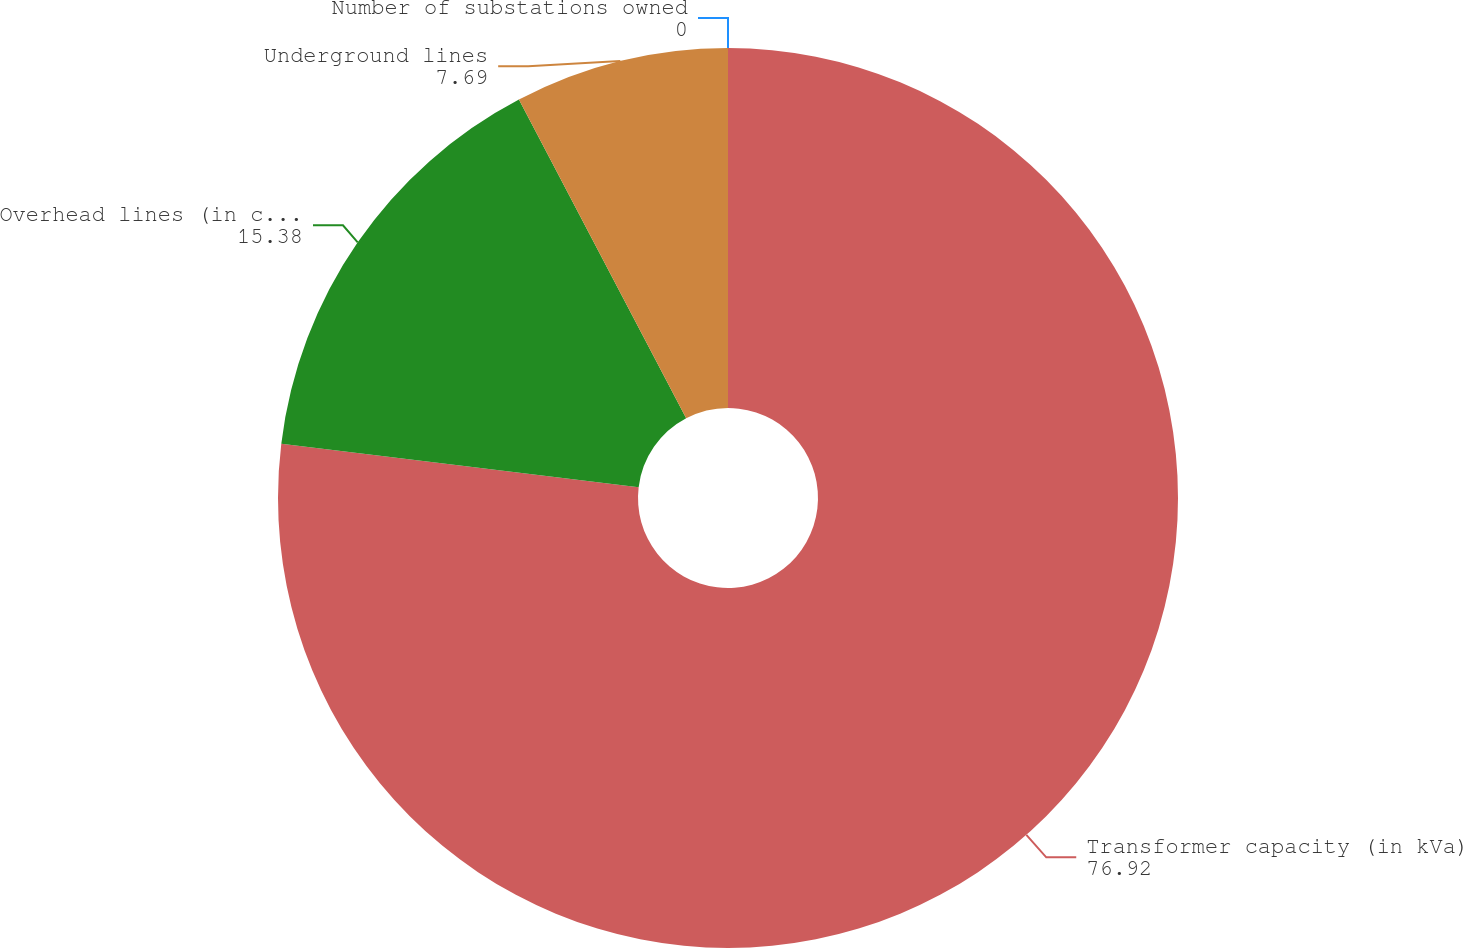Convert chart to OTSL. <chart><loc_0><loc_0><loc_500><loc_500><pie_chart><fcel>Number of substations owned<fcel>Transformer capacity (in kVa)<fcel>Overhead lines (in circuit<fcel>Underground lines<nl><fcel>0.0%<fcel>76.92%<fcel>15.38%<fcel>7.69%<nl></chart> 